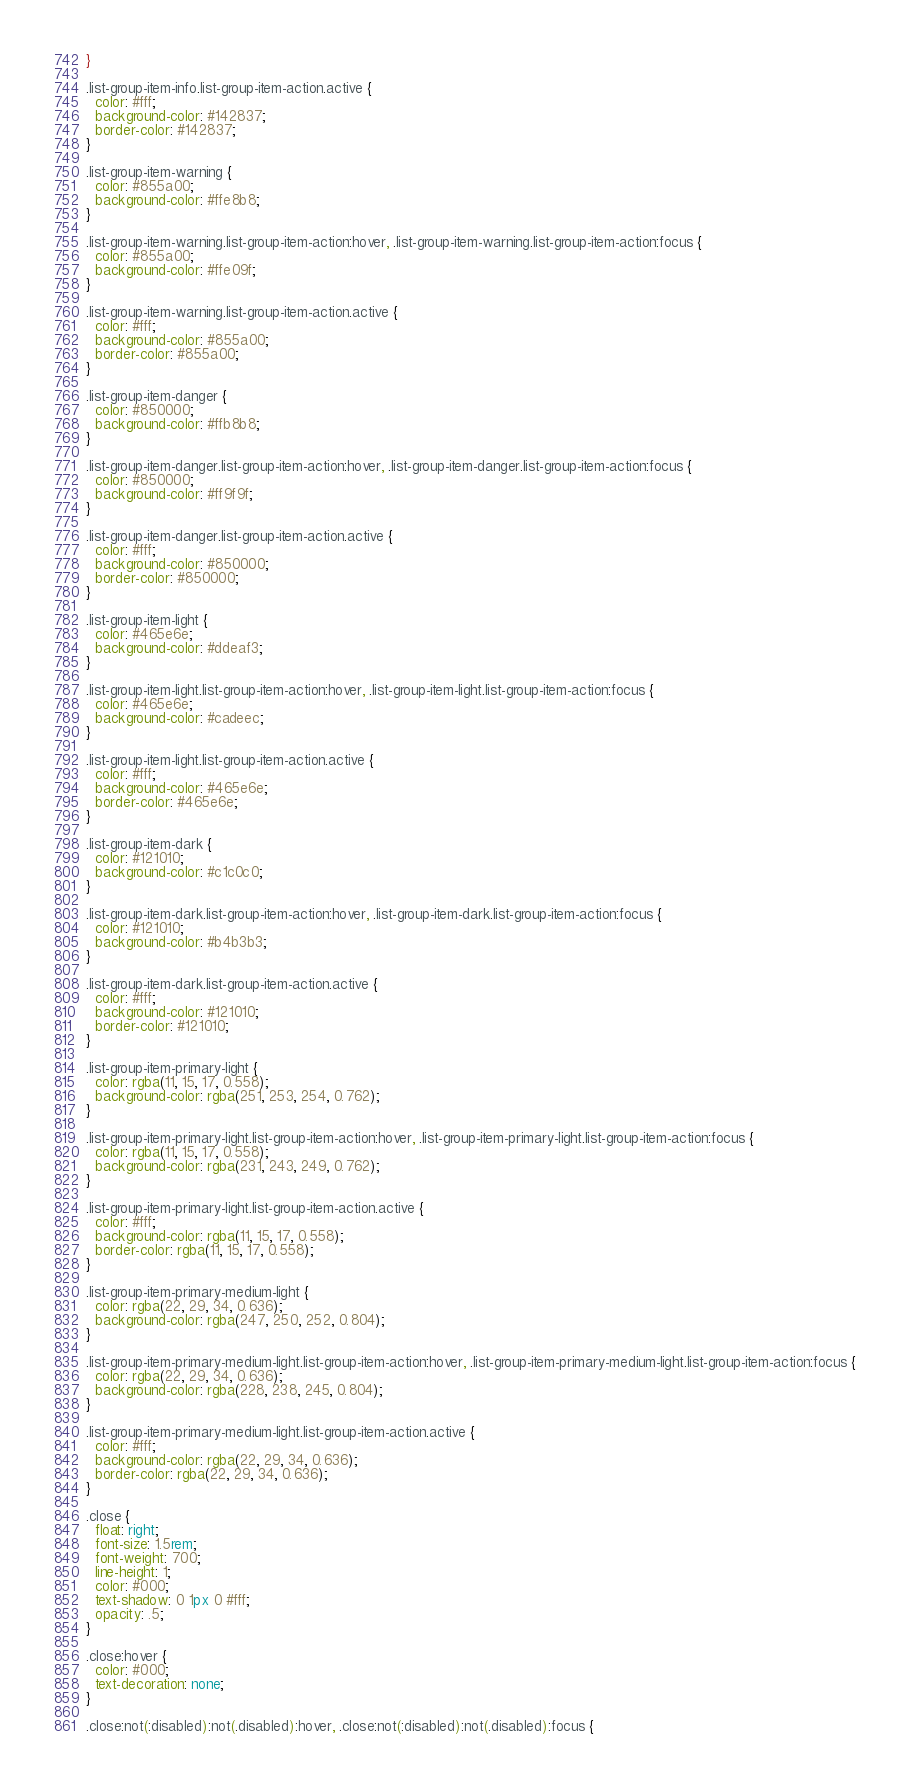<code> <loc_0><loc_0><loc_500><loc_500><_CSS_>}

.list-group-item-info.list-group-item-action.active {
  color: #fff;
  background-color: #142837;
  border-color: #142837;
}

.list-group-item-warning {
  color: #855a00;
  background-color: #ffe8b8;
}

.list-group-item-warning.list-group-item-action:hover, .list-group-item-warning.list-group-item-action:focus {
  color: #855a00;
  background-color: #ffe09f;
}

.list-group-item-warning.list-group-item-action.active {
  color: #fff;
  background-color: #855a00;
  border-color: #855a00;
}

.list-group-item-danger {
  color: #850000;
  background-color: #ffb8b8;
}

.list-group-item-danger.list-group-item-action:hover, .list-group-item-danger.list-group-item-action:focus {
  color: #850000;
  background-color: #ff9f9f;
}

.list-group-item-danger.list-group-item-action.active {
  color: #fff;
  background-color: #850000;
  border-color: #850000;
}

.list-group-item-light {
  color: #465e6e;
  background-color: #ddeaf3;
}

.list-group-item-light.list-group-item-action:hover, .list-group-item-light.list-group-item-action:focus {
  color: #465e6e;
  background-color: #cadeec;
}

.list-group-item-light.list-group-item-action.active {
  color: #fff;
  background-color: #465e6e;
  border-color: #465e6e;
}

.list-group-item-dark {
  color: #121010;
  background-color: #c1c0c0;
}

.list-group-item-dark.list-group-item-action:hover, .list-group-item-dark.list-group-item-action:focus {
  color: #121010;
  background-color: #b4b3b3;
}

.list-group-item-dark.list-group-item-action.active {
  color: #fff;
  background-color: #121010;
  border-color: #121010;
}

.list-group-item-primary-light {
  color: rgba(11, 15, 17, 0.558);
  background-color: rgba(251, 253, 254, 0.762);
}

.list-group-item-primary-light.list-group-item-action:hover, .list-group-item-primary-light.list-group-item-action:focus {
  color: rgba(11, 15, 17, 0.558);
  background-color: rgba(231, 243, 249, 0.762);
}

.list-group-item-primary-light.list-group-item-action.active {
  color: #fff;
  background-color: rgba(11, 15, 17, 0.558);
  border-color: rgba(11, 15, 17, 0.558);
}

.list-group-item-primary-medium-light {
  color: rgba(22, 29, 34, 0.636);
  background-color: rgba(247, 250, 252, 0.804);
}

.list-group-item-primary-medium-light.list-group-item-action:hover, .list-group-item-primary-medium-light.list-group-item-action:focus {
  color: rgba(22, 29, 34, 0.636);
  background-color: rgba(228, 238, 245, 0.804);
}

.list-group-item-primary-medium-light.list-group-item-action.active {
  color: #fff;
  background-color: rgba(22, 29, 34, 0.636);
  border-color: rgba(22, 29, 34, 0.636);
}

.close {
  float: right;
  font-size: 1.5rem;
  font-weight: 700;
  line-height: 1;
  color: #000;
  text-shadow: 0 1px 0 #fff;
  opacity: .5;
}

.close:hover {
  color: #000;
  text-decoration: none;
}

.close:not(:disabled):not(.disabled):hover, .close:not(:disabled):not(.disabled):focus {</code> 